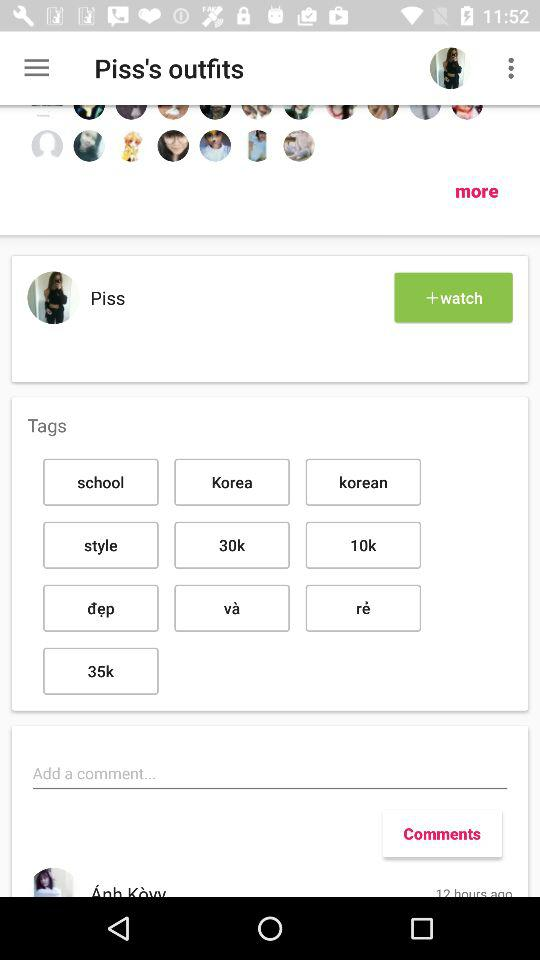What are the given tags? The given tags are "school", "Korea", "Korean", "style", "30k", "10k", "dep", "va", "re" and "35k". 